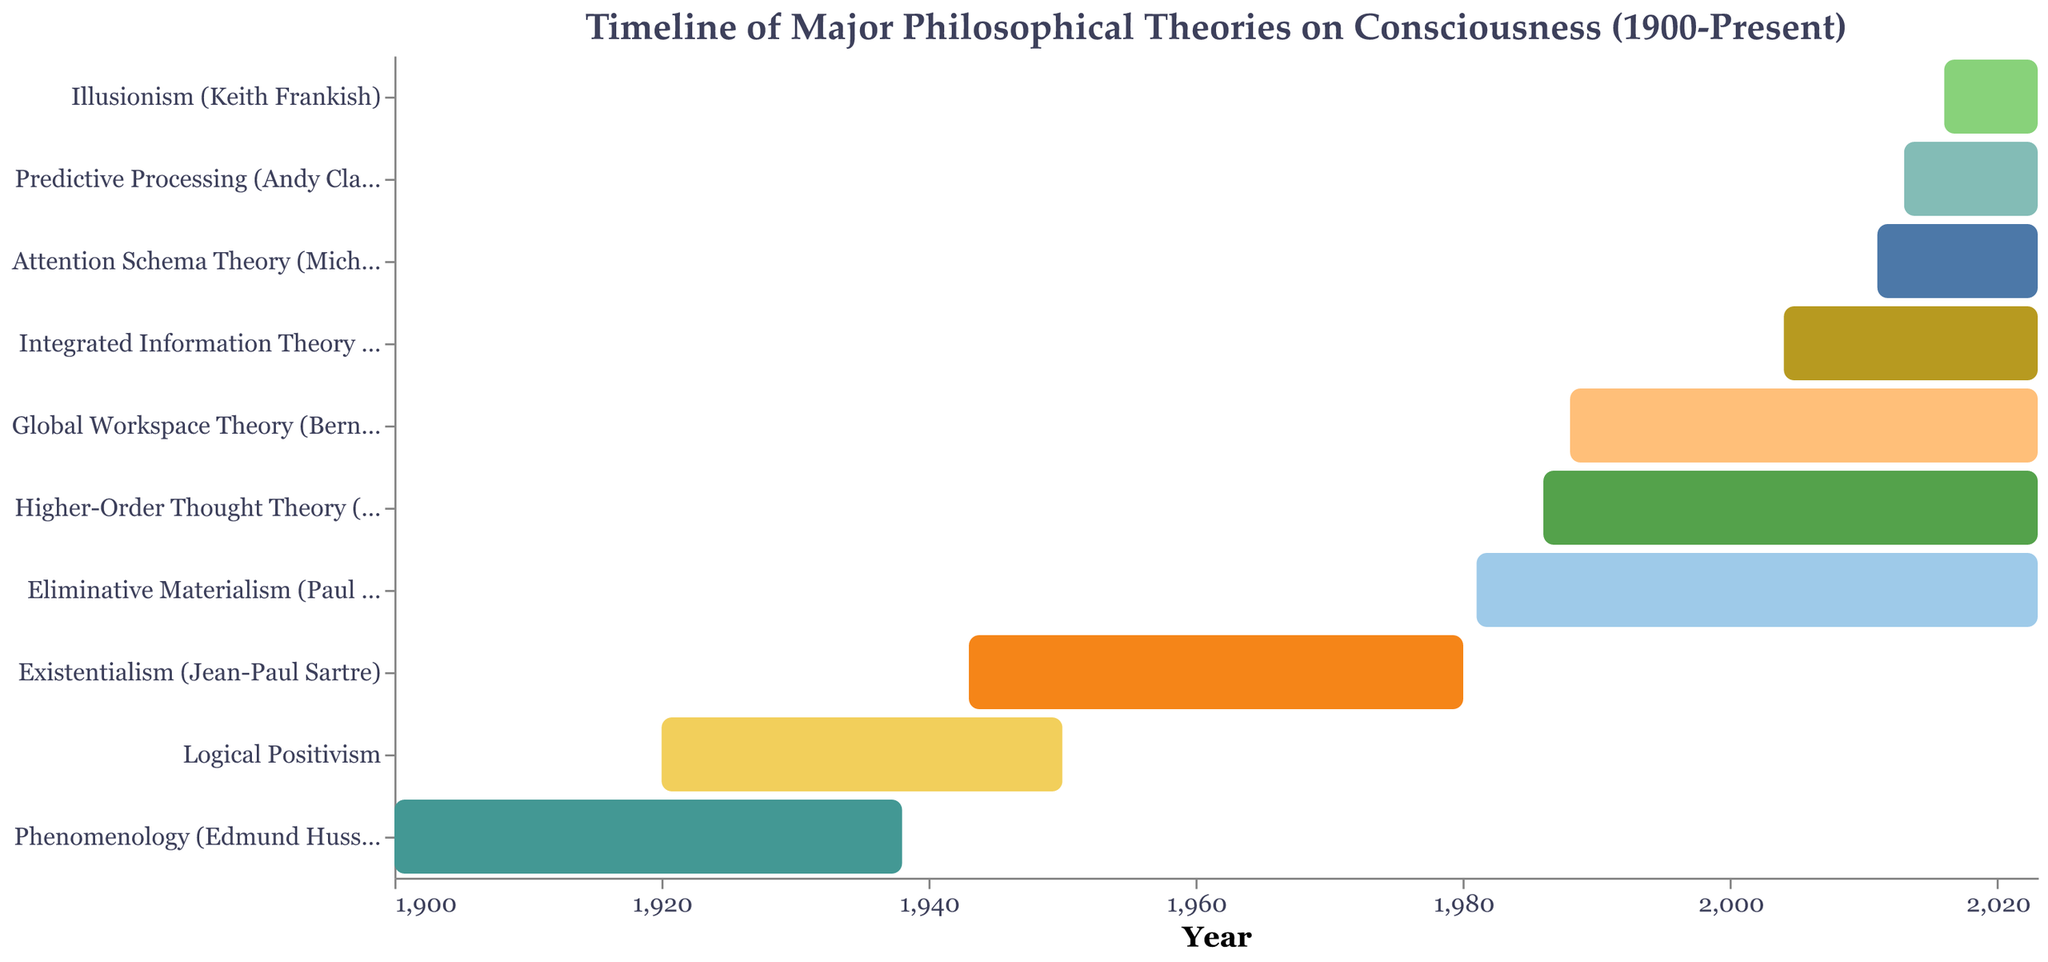What is the title of the chart? Look at the text at the top center of the chart, which specifies the title.
Answer: "Timeline of Major Philosophical Theories on Consciousness (1900-Present)" Which theory started in 1988? Identify the bar corresponding to the year 1988 in the x-axis and read the associated theory on the y-axis.
Answer: Global Workspace Theory (Bernard Baars) How many theories started after 2000? Count the number of bars that begin after the year 2000 on the x-axis.
Answer: 5 What is the time span of Phenomenology (Edmund Husserl)? Find the start and end years for Phenomenology (Edmund Husserl) and subtract the start year from the end year.
Answer: 38 years Which two theories have the most overlap in their active periods? Identify the bars that overlap the most in the x-axis range and compare their start and end points.
Answer: Higher-Order Thought Theory and Global Workspace Theory What is the range of years displayed on the x-axis? Observe the minimum and maximum values on the x-axis.
Answer: 1900 to 2023 Which theory has the shortest active period? Identify the bar with the shortest length on the x-axis and look at the start and end years.
Answer: Illusionism (Keith Frankish) What is the combined active period of theories that started in the 20th century and are still active? Sum the differences between the start year and the present year (2023) for each theory that started before 2000 and is still active.
Answer: Combined years: Eliminative Materialism = 42, Higher-Order Thought Theory = 37, Global Workspace Theory = 35. Total = 114 years Which theory spans the longest time period? Identify the bar with the longest length on the x-axis by comparing the start and end years.
Answer: Existentialism (Jean-Paul Sartre) What color is used for the Integrated Information Theory (Giulio Tononi)? Locate the bar for Integrated Information Theory and describe its color.
Answer: (Appropriate color description based on the chart's color scheme) 